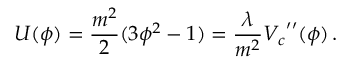Convert formula to latex. <formula><loc_0><loc_0><loc_500><loc_500>U ( \phi ) = \frac { m ^ { 2 } } { 2 } ( 3 \phi ^ { 2 } - 1 ) = \frac { \lambda } { m ^ { 2 } } { V _ { c } } ^ { \prime \prime } ( \phi ) \, .</formula> 